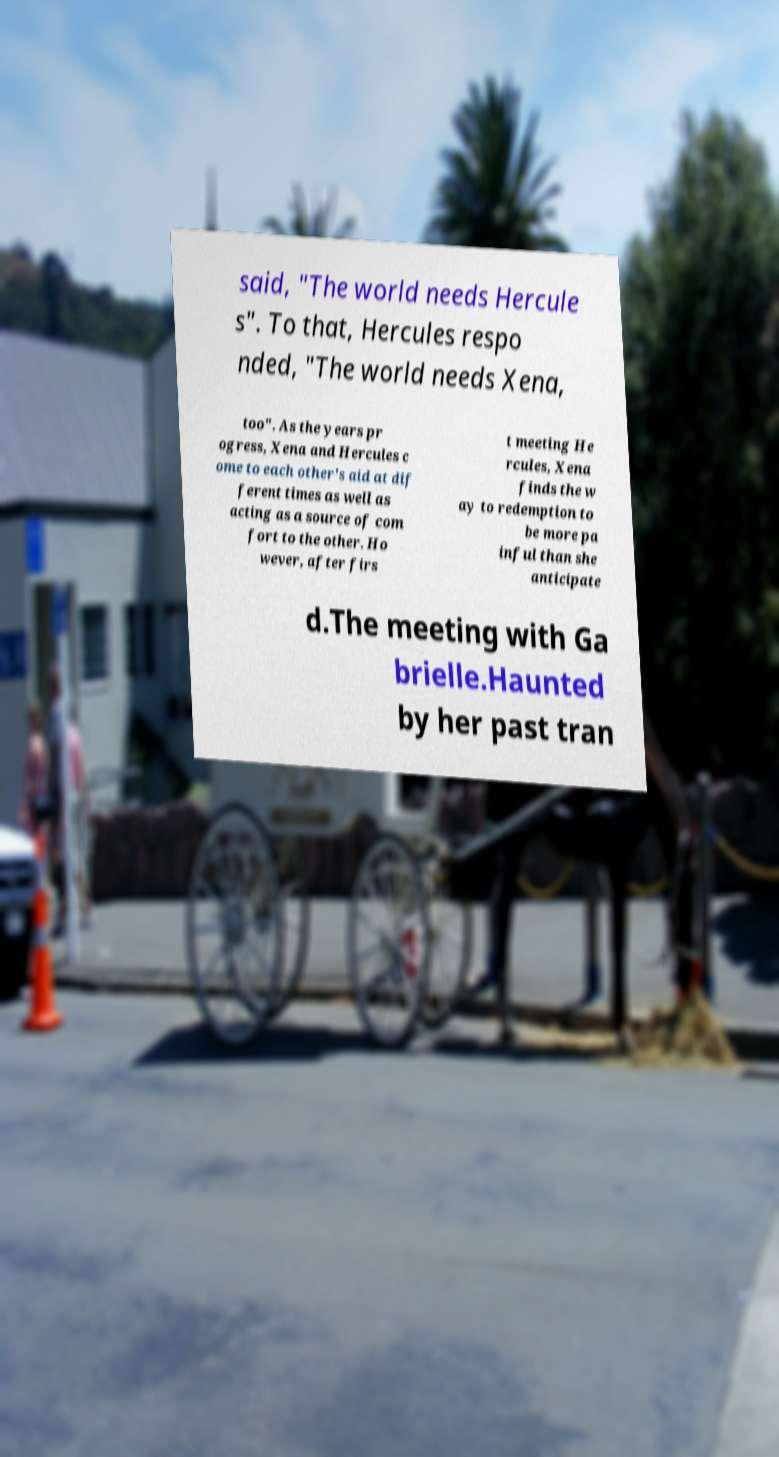I need the written content from this picture converted into text. Can you do that? said, "The world needs Hercule s". To that, Hercules respo nded, "The world needs Xena, too". As the years pr ogress, Xena and Hercules c ome to each other's aid at dif ferent times as well as acting as a source of com fort to the other. Ho wever, after firs t meeting He rcules, Xena finds the w ay to redemption to be more pa inful than she anticipate d.The meeting with Ga brielle.Haunted by her past tran 